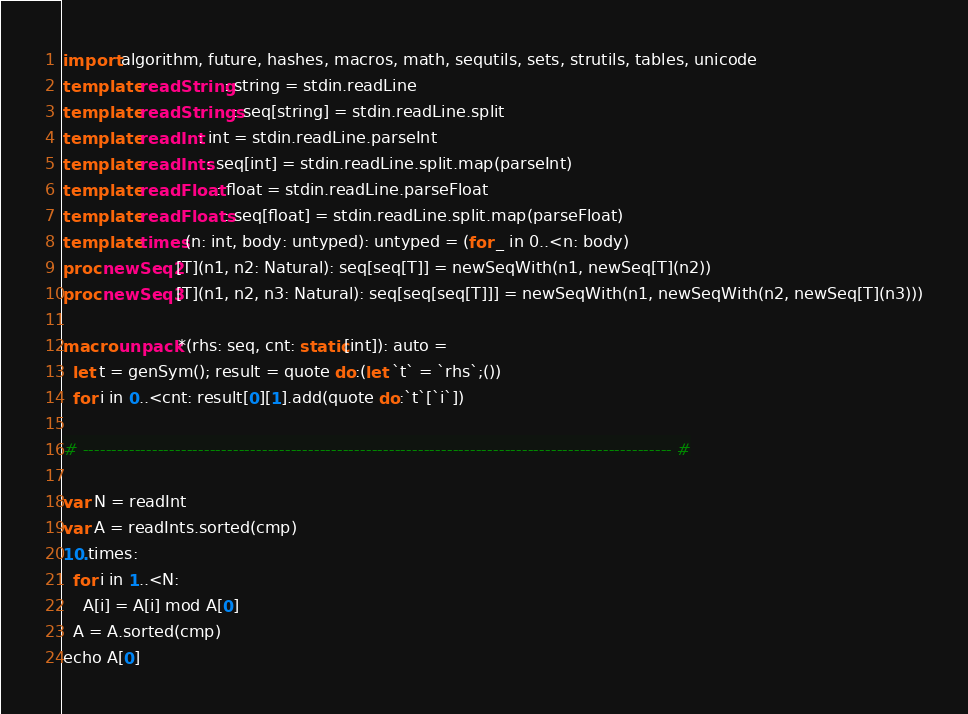<code> <loc_0><loc_0><loc_500><loc_500><_Nim_>import algorithm, future, hashes, macros, math, sequtils, sets, strutils, tables, unicode
template readString: string = stdin.readLine
template readStrings: seq[string] = stdin.readLine.split
template readInt: int = stdin.readLine.parseInt
template readInts: seq[int] = stdin.readLine.split.map(parseInt)
template readFloat: float = stdin.readLine.parseFloat
template readFloats: seq[float] = stdin.readLine.split.map(parseFloat)
template times(n: int, body: untyped): untyped = (for _ in 0..<n: body)
proc newSeq2[T](n1, n2: Natural): seq[seq[T]] = newSeqWith(n1, newSeq[T](n2))
proc newSeq3[T](n1, n2, n3: Natural): seq[seq[seq[T]]] = newSeqWith(n1, newSeqWith(n2, newSeq[T](n3)))

macro unpack*(rhs: seq, cnt: static[int]): auto =
  let t = genSym(); result = quote do:(let `t` = `rhs`;())
  for i in 0..<cnt: result[0][1].add(quote do:`t`[`i`])

# ------------------------------------------------------------------------------------------------------ #

var N = readInt
var A = readInts.sorted(cmp)
10.times:
  for i in 1..<N:
    A[i] = A[i] mod A[0]
  A = A.sorted(cmp)
echo A[0]
</code> 